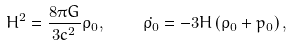<formula> <loc_0><loc_0><loc_500><loc_500>H ^ { 2 } = \frac { 8 \pi G } { 3 c ^ { 2 } } \rho _ { 0 } , \quad \dot { \rho _ { 0 } } = - 3 H \left ( \rho _ { 0 } + p _ { 0 } \right ) ,</formula> 